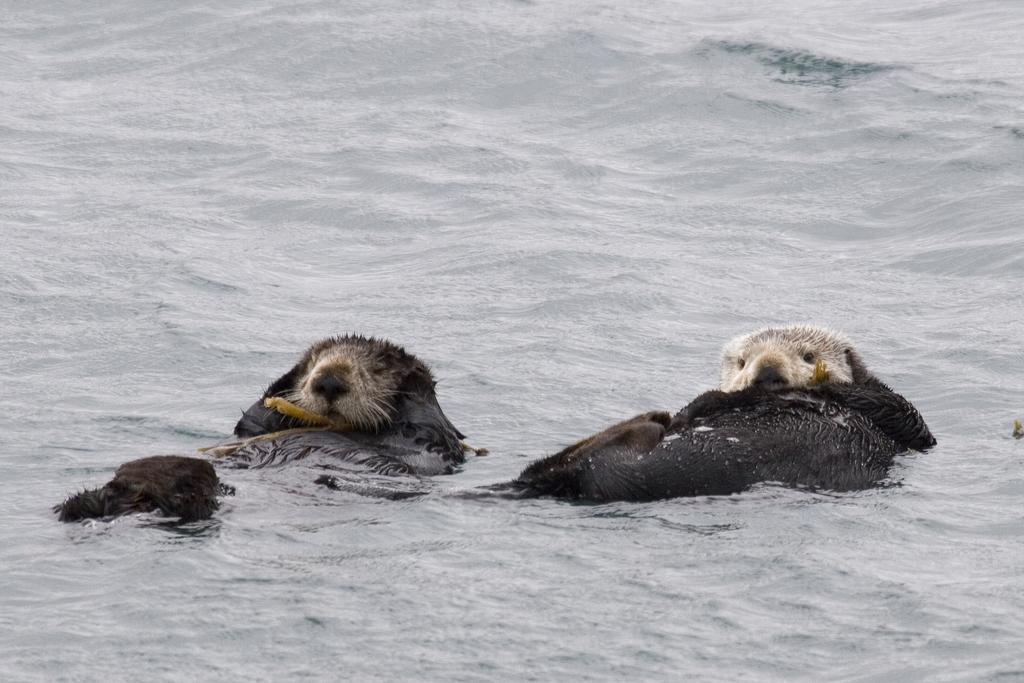Can you describe this image briefly? In this image I see 2 animals which are of black and white in color and they're in the water. 